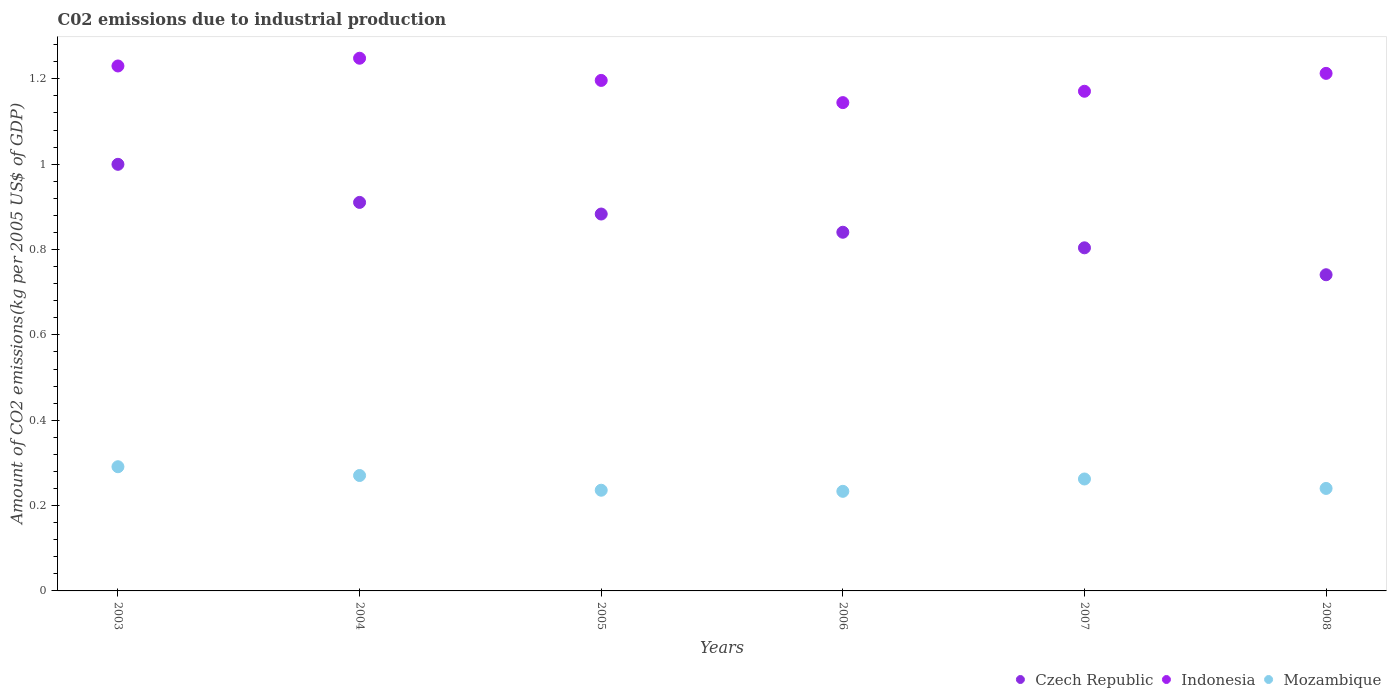Is the number of dotlines equal to the number of legend labels?
Provide a succinct answer. Yes. What is the amount of CO2 emitted due to industrial production in Mozambique in 2004?
Give a very brief answer. 0.27. Across all years, what is the maximum amount of CO2 emitted due to industrial production in Czech Republic?
Provide a succinct answer. 1. Across all years, what is the minimum amount of CO2 emitted due to industrial production in Czech Republic?
Your response must be concise. 0.74. In which year was the amount of CO2 emitted due to industrial production in Czech Republic maximum?
Provide a short and direct response. 2003. In which year was the amount of CO2 emitted due to industrial production in Czech Republic minimum?
Offer a terse response. 2008. What is the total amount of CO2 emitted due to industrial production in Czech Republic in the graph?
Keep it short and to the point. 5.18. What is the difference between the amount of CO2 emitted due to industrial production in Indonesia in 2004 and that in 2007?
Give a very brief answer. 0.08. What is the difference between the amount of CO2 emitted due to industrial production in Indonesia in 2004 and the amount of CO2 emitted due to industrial production in Czech Republic in 2007?
Keep it short and to the point. 0.44. What is the average amount of CO2 emitted due to industrial production in Czech Republic per year?
Your response must be concise. 0.86. In the year 2006, what is the difference between the amount of CO2 emitted due to industrial production in Indonesia and amount of CO2 emitted due to industrial production in Mozambique?
Your answer should be compact. 0.91. In how many years, is the amount of CO2 emitted due to industrial production in Czech Republic greater than 0.7600000000000001 kg?
Provide a short and direct response. 5. What is the ratio of the amount of CO2 emitted due to industrial production in Czech Republic in 2004 to that in 2007?
Provide a short and direct response. 1.13. Is the difference between the amount of CO2 emitted due to industrial production in Indonesia in 2003 and 2004 greater than the difference between the amount of CO2 emitted due to industrial production in Mozambique in 2003 and 2004?
Give a very brief answer. No. What is the difference between the highest and the second highest amount of CO2 emitted due to industrial production in Czech Republic?
Make the answer very short. 0.09. What is the difference between the highest and the lowest amount of CO2 emitted due to industrial production in Mozambique?
Your answer should be very brief. 0.06. In how many years, is the amount of CO2 emitted due to industrial production in Mozambique greater than the average amount of CO2 emitted due to industrial production in Mozambique taken over all years?
Ensure brevity in your answer.  3. Is the sum of the amount of CO2 emitted due to industrial production in Indonesia in 2003 and 2006 greater than the maximum amount of CO2 emitted due to industrial production in Mozambique across all years?
Offer a very short reply. Yes. Is it the case that in every year, the sum of the amount of CO2 emitted due to industrial production in Czech Republic and amount of CO2 emitted due to industrial production in Mozambique  is greater than the amount of CO2 emitted due to industrial production in Indonesia?
Your response must be concise. No. Does the amount of CO2 emitted due to industrial production in Czech Republic monotonically increase over the years?
Provide a short and direct response. No. Is the amount of CO2 emitted due to industrial production in Mozambique strictly greater than the amount of CO2 emitted due to industrial production in Czech Republic over the years?
Make the answer very short. No. Is the amount of CO2 emitted due to industrial production in Indonesia strictly less than the amount of CO2 emitted due to industrial production in Czech Republic over the years?
Offer a terse response. No. How many dotlines are there?
Make the answer very short. 3. How many years are there in the graph?
Provide a succinct answer. 6. Does the graph contain any zero values?
Your answer should be compact. No. How are the legend labels stacked?
Offer a very short reply. Horizontal. What is the title of the graph?
Provide a short and direct response. C02 emissions due to industrial production. Does "Croatia" appear as one of the legend labels in the graph?
Your answer should be very brief. No. What is the label or title of the Y-axis?
Your answer should be very brief. Amount of CO2 emissions(kg per 2005 US$ of GDP). What is the Amount of CO2 emissions(kg per 2005 US$ of GDP) of Czech Republic in 2003?
Your response must be concise. 1. What is the Amount of CO2 emissions(kg per 2005 US$ of GDP) of Indonesia in 2003?
Provide a short and direct response. 1.23. What is the Amount of CO2 emissions(kg per 2005 US$ of GDP) in Mozambique in 2003?
Provide a succinct answer. 0.29. What is the Amount of CO2 emissions(kg per 2005 US$ of GDP) of Czech Republic in 2004?
Provide a short and direct response. 0.91. What is the Amount of CO2 emissions(kg per 2005 US$ of GDP) of Indonesia in 2004?
Your answer should be compact. 1.25. What is the Amount of CO2 emissions(kg per 2005 US$ of GDP) in Mozambique in 2004?
Give a very brief answer. 0.27. What is the Amount of CO2 emissions(kg per 2005 US$ of GDP) of Czech Republic in 2005?
Ensure brevity in your answer.  0.88. What is the Amount of CO2 emissions(kg per 2005 US$ of GDP) of Indonesia in 2005?
Provide a short and direct response. 1.2. What is the Amount of CO2 emissions(kg per 2005 US$ of GDP) in Mozambique in 2005?
Provide a succinct answer. 0.24. What is the Amount of CO2 emissions(kg per 2005 US$ of GDP) of Czech Republic in 2006?
Provide a short and direct response. 0.84. What is the Amount of CO2 emissions(kg per 2005 US$ of GDP) in Indonesia in 2006?
Your answer should be compact. 1.14. What is the Amount of CO2 emissions(kg per 2005 US$ of GDP) of Mozambique in 2006?
Ensure brevity in your answer.  0.23. What is the Amount of CO2 emissions(kg per 2005 US$ of GDP) of Czech Republic in 2007?
Provide a short and direct response. 0.8. What is the Amount of CO2 emissions(kg per 2005 US$ of GDP) of Indonesia in 2007?
Provide a short and direct response. 1.17. What is the Amount of CO2 emissions(kg per 2005 US$ of GDP) of Mozambique in 2007?
Your answer should be compact. 0.26. What is the Amount of CO2 emissions(kg per 2005 US$ of GDP) of Czech Republic in 2008?
Offer a very short reply. 0.74. What is the Amount of CO2 emissions(kg per 2005 US$ of GDP) in Indonesia in 2008?
Give a very brief answer. 1.21. What is the Amount of CO2 emissions(kg per 2005 US$ of GDP) of Mozambique in 2008?
Give a very brief answer. 0.24. Across all years, what is the maximum Amount of CO2 emissions(kg per 2005 US$ of GDP) in Czech Republic?
Make the answer very short. 1. Across all years, what is the maximum Amount of CO2 emissions(kg per 2005 US$ of GDP) of Indonesia?
Offer a terse response. 1.25. Across all years, what is the maximum Amount of CO2 emissions(kg per 2005 US$ of GDP) in Mozambique?
Keep it short and to the point. 0.29. Across all years, what is the minimum Amount of CO2 emissions(kg per 2005 US$ of GDP) of Czech Republic?
Your answer should be compact. 0.74. Across all years, what is the minimum Amount of CO2 emissions(kg per 2005 US$ of GDP) of Indonesia?
Provide a succinct answer. 1.14. Across all years, what is the minimum Amount of CO2 emissions(kg per 2005 US$ of GDP) in Mozambique?
Ensure brevity in your answer.  0.23. What is the total Amount of CO2 emissions(kg per 2005 US$ of GDP) of Czech Republic in the graph?
Your answer should be very brief. 5.18. What is the total Amount of CO2 emissions(kg per 2005 US$ of GDP) in Indonesia in the graph?
Ensure brevity in your answer.  7.2. What is the total Amount of CO2 emissions(kg per 2005 US$ of GDP) in Mozambique in the graph?
Make the answer very short. 1.53. What is the difference between the Amount of CO2 emissions(kg per 2005 US$ of GDP) in Czech Republic in 2003 and that in 2004?
Offer a terse response. 0.09. What is the difference between the Amount of CO2 emissions(kg per 2005 US$ of GDP) of Indonesia in 2003 and that in 2004?
Ensure brevity in your answer.  -0.02. What is the difference between the Amount of CO2 emissions(kg per 2005 US$ of GDP) in Mozambique in 2003 and that in 2004?
Your response must be concise. 0.02. What is the difference between the Amount of CO2 emissions(kg per 2005 US$ of GDP) of Czech Republic in 2003 and that in 2005?
Keep it short and to the point. 0.12. What is the difference between the Amount of CO2 emissions(kg per 2005 US$ of GDP) in Indonesia in 2003 and that in 2005?
Offer a very short reply. 0.03. What is the difference between the Amount of CO2 emissions(kg per 2005 US$ of GDP) in Mozambique in 2003 and that in 2005?
Give a very brief answer. 0.06. What is the difference between the Amount of CO2 emissions(kg per 2005 US$ of GDP) in Czech Republic in 2003 and that in 2006?
Ensure brevity in your answer.  0.16. What is the difference between the Amount of CO2 emissions(kg per 2005 US$ of GDP) of Indonesia in 2003 and that in 2006?
Your answer should be compact. 0.09. What is the difference between the Amount of CO2 emissions(kg per 2005 US$ of GDP) of Mozambique in 2003 and that in 2006?
Provide a short and direct response. 0.06. What is the difference between the Amount of CO2 emissions(kg per 2005 US$ of GDP) of Czech Republic in 2003 and that in 2007?
Give a very brief answer. 0.2. What is the difference between the Amount of CO2 emissions(kg per 2005 US$ of GDP) of Indonesia in 2003 and that in 2007?
Provide a succinct answer. 0.06. What is the difference between the Amount of CO2 emissions(kg per 2005 US$ of GDP) in Mozambique in 2003 and that in 2007?
Provide a succinct answer. 0.03. What is the difference between the Amount of CO2 emissions(kg per 2005 US$ of GDP) of Czech Republic in 2003 and that in 2008?
Offer a terse response. 0.26. What is the difference between the Amount of CO2 emissions(kg per 2005 US$ of GDP) in Indonesia in 2003 and that in 2008?
Keep it short and to the point. 0.02. What is the difference between the Amount of CO2 emissions(kg per 2005 US$ of GDP) in Mozambique in 2003 and that in 2008?
Ensure brevity in your answer.  0.05. What is the difference between the Amount of CO2 emissions(kg per 2005 US$ of GDP) of Czech Republic in 2004 and that in 2005?
Provide a succinct answer. 0.03. What is the difference between the Amount of CO2 emissions(kg per 2005 US$ of GDP) of Indonesia in 2004 and that in 2005?
Offer a terse response. 0.05. What is the difference between the Amount of CO2 emissions(kg per 2005 US$ of GDP) of Mozambique in 2004 and that in 2005?
Your answer should be very brief. 0.03. What is the difference between the Amount of CO2 emissions(kg per 2005 US$ of GDP) of Czech Republic in 2004 and that in 2006?
Provide a short and direct response. 0.07. What is the difference between the Amount of CO2 emissions(kg per 2005 US$ of GDP) in Indonesia in 2004 and that in 2006?
Provide a short and direct response. 0.1. What is the difference between the Amount of CO2 emissions(kg per 2005 US$ of GDP) of Mozambique in 2004 and that in 2006?
Ensure brevity in your answer.  0.04. What is the difference between the Amount of CO2 emissions(kg per 2005 US$ of GDP) of Czech Republic in 2004 and that in 2007?
Your answer should be compact. 0.11. What is the difference between the Amount of CO2 emissions(kg per 2005 US$ of GDP) of Indonesia in 2004 and that in 2007?
Your response must be concise. 0.08. What is the difference between the Amount of CO2 emissions(kg per 2005 US$ of GDP) in Mozambique in 2004 and that in 2007?
Your response must be concise. 0.01. What is the difference between the Amount of CO2 emissions(kg per 2005 US$ of GDP) in Czech Republic in 2004 and that in 2008?
Provide a succinct answer. 0.17. What is the difference between the Amount of CO2 emissions(kg per 2005 US$ of GDP) in Indonesia in 2004 and that in 2008?
Offer a terse response. 0.04. What is the difference between the Amount of CO2 emissions(kg per 2005 US$ of GDP) in Mozambique in 2004 and that in 2008?
Give a very brief answer. 0.03. What is the difference between the Amount of CO2 emissions(kg per 2005 US$ of GDP) of Czech Republic in 2005 and that in 2006?
Provide a succinct answer. 0.04. What is the difference between the Amount of CO2 emissions(kg per 2005 US$ of GDP) of Indonesia in 2005 and that in 2006?
Keep it short and to the point. 0.05. What is the difference between the Amount of CO2 emissions(kg per 2005 US$ of GDP) in Mozambique in 2005 and that in 2006?
Offer a very short reply. 0. What is the difference between the Amount of CO2 emissions(kg per 2005 US$ of GDP) of Czech Republic in 2005 and that in 2007?
Offer a terse response. 0.08. What is the difference between the Amount of CO2 emissions(kg per 2005 US$ of GDP) in Indonesia in 2005 and that in 2007?
Ensure brevity in your answer.  0.03. What is the difference between the Amount of CO2 emissions(kg per 2005 US$ of GDP) in Mozambique in 2005 and that in 2007?
Your answer should be compact. -0.03. What is the difference between the Amount of CO2 emissions(kg per 2005 US$ of GDP) in Czech Republic in 2005 and that in 2008?
Make the answer very short. 0.14. What is the difference between the Amount of CO2 emissions(kg per 2005 US$ of GDP) in Indonesia in 2005 and that in 2008?
Keep it short and to the point. -0.02. What is the difference between the Amount of CO2 emissions(kg per 2005 US$ of GDP) in Mozambique in 2005 and that in 2008?
Your answer should be very brief. -0. What is the difference between the Amount of CO2 emissions(kg per 2005 US$ of GDP) in Czech Republic in 2006 and that in 2007?
Provide a short and direct response. 0.04. What is the difference between the Amount of CO2 emissions(kg per 2005 US$ of GDP) of Indonesia in 2006 and that in 2007?
Make the answer very short. -0.03. What is the difference between the Amount of CO2 emissions(kg per 2005 US$ of GDP) in Mozambique in 2006 and that in 2007?
Make the answer very short. -0.03. What is the difference between the Amount of CO2 emissions(kg per 2005 US$ of GDP) in Czech Republic in 2006 and that in 2008?
Offer a terse response. 0.1. What is the difference between the Amount of CO2 emissions(kg per 2005 US$ of GDP) in Indonesia in 2006 and that in 2008?
Offer a very short reply. -0.07. What is the difference between the Amount of CO2 emissions(kg per 2005 US$ of GDP) of Mozambique in 2006 and that in 2008?
Offer a very short reply. -0.01. What is the difference between the Amount of CO2 emissions(kg per 2005 US$ of GDP) of Czech Republic in 2007 and that in 2008?
Make the answer very short. 0.06. What is the difference between the Amount of CO2 emissions(kg per 2005 US$ of GDP) of Indonesia in 2007 and that in 2008?
Your response must be concise. -0.04. What is the difference between the Amount of CO2 emissions(kg per 2005 US$ of GDP) of Mozambique in 2007 and that in 2008?
Give a very brief answer. 0.02. What is the difference between the Amount of CO2 emissions(kg per 2005 US$ of GDP) of Czech Republic in 2003 and the Amount of CO2 emissions(kg per 2005 US$ of GDP) of Indonesia in 2004?
Give a very brief answer. -0.25. What is the difference between the Amount of CO2 emissions(kg per 2005 US$ of GDP) of Czech Republic in 2003 and the Amount of CO2 emissions(kg per 2005 US$ of GDP) of Mozambique in 2004?
Provide a succinct answer. 0.73. What is the difference between the Amount of CO2 emissions(kg per 2005 US$ of GDP) in Indonesia in 2003 and the Amount of CO2 emissions(kg per 2005 US$ of GDP) in Mozambique in 2004?
Keep it short and to the point. 0.96. What is the difference between the Amount of CO2 emissions(kg per 2005 US$ of GDP) in Czech Republic in 2003 and the Amount of CO2 emissions(kg per 2005 US$ of GDP) in Indonesia in 2005?
Your answer should be compact. -0.2. What is the difference between the Amount of CO2 emissions(kg per 2005 US$ of GDP) of Czech Republic in 2003 and the Amount of CO2 emissions(kg per 2005 US$ of GDP) of Mozambique in 2005?
Provide a short and direct response. 0.76. What is the difference between the Amount of CO2 emissions(kg per 2005 US$ of GDP) of Czech Republic in 2003 and the Amount of CO2 emissions(kg per 2005 US$ of GDP) of Indonesia in 2006?
Ensure brevity in your answer.  -0.14. What is the difference between the Amount of CO2 emissions(kg per 2005 US$ of GDP) of Czech Republic in 2003 and the Amount of CO2 emissions(kg per 2005 US$ of GDP) of Mozambique in 2006?
Give a very brief answer. 0.77. What is the difference between the Amount of CO2 emissions(kg per 2005 US$ of GDP) of Czech Republic in 2003 and the Amount of CO2 emissions(kg per 2005 US$ of GDP) of Indonesia in 2007?
Give a very brief answer. -0.17. What is the difference between the Amount of CO2 emissions(kg per 2005 US$ of GDP) of Czech Republic in 2003 and the Amount of CO2 emissions(kg per 2005 US$ of GDP) of Mozambique in 2007?
Ensure brevity in your answer.  0.74. What is the difference between the Amount of CO2 emissions(kg per 2005 US$ of GDP) of Indonesia in 2003 and the Amount of CO2 emissions(kg per 2005 US$ of GDP) of Mozambique in 2007?
Your response must be concise. 0.97. What is the difference between the Amount of CO2 emissions(kg per 2005 US$ of GDP) in Czech Republic in 2003 and the Amount of CO2 emissions(kg per 2005 US$ of GDP) in Indonesia in 2008?
Keep it short and to the point. -0.21. What is the difference between the Amount of CO2 emissions(kg per 2005 US$ of GDP) in Czech Republic in 2003 and the Amount of CO2 emissions(kg per 2005 US$ of GDP) in Mozambique in 2008?
Keep it short and to the point. 0.76. What is the difference between the Amount of CO2 emissions(kg per 2005 US$ of GDP) of Indonesia in 2003 and the Amount of CO2 emissions(kg per 2005 US$ of GDP) of Mozambique in 2008?
Your answer should be very brief. 0.99. What is the difference between the Amount of CO2 emissions(kg per 2005 US$ of GDP) in Czech Republic in 2004 and the Amount of CO2 emissions(kg per 2005 US$ of GDP) in Indonesia in 2005?
Provide a succinct answer. -0.29. What is the difference between the Amount of CO2 emissions(kg per 2005 US$ of GDP) in Czech Republic in 2004 and the Amount of CO2 emissions(kg per 2005 US$ of GDP) in Mozambique in 2005?
Offer a very short reply. 0.67. What is the difference between the Amount of CO2 emissions(kg per 2005 US$ of GDP) in Indonesia in 2004 and the Amount of CO2 emissions(kg per 2005 US$ of GDP) in Mozambique in 2005?
Keep it short and to the point. 1.01. What is the difference between the Amount of CO2 emissions(kg per 2005 US$ of GDP) of Czech Republic in 2004 and the Amount of CO2 emissions(kg per 2005 US$ of GDP) of Indonesia in 2006?
Offer a very short reply. -0.23. What is the difference between the Amount of CO2 emissions(kg per 2005 US$ of GDP) of Czech Republic in 2004 and the Amount of CO2 emissions(kg per 2005 US$ of GDP) of Mozambique in 2006?
Make the answer very short. 0.68. What is the difference between the Amount of CO2 emissions(kg per 2005 US$ of GDP) of Indonesia in 2004 and the Amount of CO2 emissions(kg per 2005 US$ of GDP) of Mozambique in 2006?
Your answer should be very brief. 1.01. What is the difference between the Amount of CO2 emissions(kg per 2005 US$ of GDP) in Czech Republic in 2004 and the Amount of CO2 emissions(kg per 2005 US$ of GDP) in Indonesia in 2007?
Ensure brevity in your answer.  -0.26. What is the difference between the Amount of CO2 emissions(kg per 2005 US$ of GDP) of Czech Republic in 2004 and the Amount of CO2 emissions(kg per 2005 US$ of GDP) of Mozambique in 2007?
Your answer should be compact. 0.65. What is the difference between the Amount of CO2 emissions(kg per 2005 US$ of GDP) in Czech Republic in 2004 and the Amount of CO2 emissions(kg per 2005 US$ of GDP) in Indonesia in 2008?
Give a very brief answer. -0.3. What is the difference between the Amount of CO2 emissions(kg per 2005 US$ of GDP) of Czech Republic in 2004 and the Amount of CO2 emissions(kg per 2005 US$ of GDP) of Mozambique in 2008?
Offer a very short reply. 0.67. What is the difference between the Amount of CO2 emissions(kg per 2005 US$ of GDP) in Indonesia in 2004 and the Amount of CO2 emissions(kg per 2005 US$ of GDP) in Mozambique in 2008?
Offer a terse response. 1.01. What is the difference between the Amount of CO2 emissions(kg per 2005 US$ of GDP) of Czech Republic in 2005 and the Amount of CO2 emissions(kg per 2005 US$ of GDP) of Indonesia in 2006?
Ensure brevity in your answer.  -0.26. What is the difference between the Amount of CO2 emissions(kg per 2005 US$ of GDP) of Czech Republic in 2005 and the Amount of CO2 emissions(kg per 2005 US$ of GDP) of Mozambique in 2006?
Your response must be concise. 0.65. What is the difference between the Amount of CO2 emissions(kg per 2005 US$ of GDP) of Indonesia in 2005 and the Amount of CO2 emissions(kg per 2005 US$ of GDP) of Mozambique in 2006?
Ensure brevity in your answer.  0.96. What is the difference between the Amount of CO2 emissions(kg per 2005 US$ of GDP) in Czech Republic in 2005 and the Amount of CO2 emissions(kg per 2005 US$ of GDP) in Indonesia in 2007?
Offer a very short reply. -0.29. What is the difference between the Amount of CO2 emissions(kg per 2005 US$ of GDP) of Czech Republic in 2005 and the Amount of CO2 emissions(kg per 2005 US$ of GDP) of Mozambique in 2007?
Your answer should be very brief. 0.62. What is the difference between the Amount of CO2 emissions(kg per 2005 US$ of GDP) in Indonesia in 2005 and the Amount of CO2 emissions(kg per 2005 US$ of GDP) in Mozambique in 2007?
Your answer should be very brief. 0.93. What is the difference between the Amount of CO2 emissions(kg per 2005 US$ of GDP) of Czech Republic in 2005 and the Amount of CO2 emissions(kg per 2005 US$ of GDP) of Indonesia in 2008?
Make the answer very short. -0.33. What is the difference between the Amount of CO2 emissions(kg per 2005 US$ of GDP) in Czech Republic in 2005 and the Amount of CO2 emissions(kg per 2005 US$ of GDP) in Mozambique in 2008?
Your answer should be very brief. 0.64. What is the difference between the Amount of CO2 emissions(kg per 2005 US$ of GDP) of Indonesia in 2005 and the Amount of CO2 emissions(kg per 2005 US$ of GDP) of Mozambique in 2008?
Your answer should be very brief. 0.96. What is the difference between the Amount of CO2 emissions(kg per 2005 US$ of GDP) in Czech Republic in 2006 and the Amount of CO2 emissions(kg per 2005 US$ of GDP) in Indonesia in 2007?
Make the answer very short. -0.33. What is the difference between the Amount of CO2 emissions(kg per 2005 US$ of GDP) of Czech Republic in 2006 and the Amount of CO2 emissions(kg per 2005 US$ of GDP) of Mozambique in 2007?
Your response must be concise. 0.58. What is the difference between the Amount of CO2 emissions(kg per 2005 US$ of GDP) in Indonesia in 2006 and the Amount of CO2 emissions(kg per 2005 US$ of GDP) in Mozambique in 2007?
Provide a succinct answer. 0.88. What is the difference between the Amount of CO2 emissions(kg per 2005 US$ of GDP) in Czech Republic in 2006 and the Amount of CO2 emissions(kg per 2005 US$ of GDP) in Indonesia in 2008?
Your answer should be very brief. -0.37. What is the difference between the Amount of CO2 emissions(kg per 2005 US$ of GDP) of Czech Republic in 2006 and the Amount of CO2 emissions(kg per 2005 US$ of GDP) of Mozambique in 2008?
Keep it short and to the point. 0.6. What is the difference between the Amount of CO2 emissions(kg per 2005 US$ of GDP) in Indonesia in 2006 and the Amount of CO2 emissions(kg per 2005 US$ of GDP) in Mozambique in 2008?
Provide a short and direct response. 0.9. What is the difference between the Amount of CO2 emissions(kg per 2005 US$ of GDP) of Czech Republic in 2007 and the Amount of CO2 emissions(kg per 2005 US$ of GDP) of Indonesia in 2008?
Offer a very short reply. -0.41. What is the difference between the Amount of CO2 emissions(kg per 2005 US$ of GDP) in Czech Republic in 2007 and the Amount of CO2 emissions(kg per 2005 US$ of GDP) in Mozambique in 2008?
Provide a succinct answer. 0.56. What is the difference between the Amount of CO2 emissions(kg per 2005 US$ of GDP) of Indonesia in 2007 and the Amount of CO2 emissions(kg per 2005 US$ of GDP) of Mozambique in 2008?
Provide a succinct answer. 0.93. What is the average Amount of CO2 emissions(kg per 2005 US$ of GDP) in Czech Republic per year?
Your response must be concise. 0.86. What is the average Amount of CO2 emissions(kg per 2005 US$ of GDP) in Indonesia per year?
Provide a short and direct response. 1.2. What is the average Amount of CO2 emissions(kg per 2005 US$ of GDP) of Mozambique per year?
Your answer should be compact. 0.26. In the year 2003, what is the difference between the Amount of CO2 emissions(kg per 2005 US$ of GDP) of Czech Republic and Amount of CO2 emissions(kg per 2005 US$ of GDP) of Indonesia?
Offer a terse response. -0.23. In the year 2003, what is the difference between the Amount of CO2 emissions(kg per 2005 US$ of GDP) of Czech Republic and Amount of CO2 emissions(kg per 2005 US$ of GDP) of Mozambique?
Keep it short and to the point. 0.71. In the year 2003, what is the difference between the Amount of CO2 emissions(kg per 2005 US$ of GDP) of Indonesia and Amount of CO2 emissions(kg per 2005 US$ of GDP) of Mozambique?
Provide a succinct answer. 0.94. In the year 2004, what is the difference between the Amount of CO2 emissions(kg per 2005 US$ of GDP) in Czech Republic and Amount of CO2 emissions(kg per 2005 US$ of GDP) in Indonesia?
Your response must be concise. -0.34. In the year 2004, what is the difference between the Amount of CO2 emissions(kg per 2005 US$ of GDP) of Czech Republic and Amount of CO2 emissions(kg per 2005 US$ of GDP) of Mozambique?
Offer a terse response. 0.64. In the year 2004, what is the difference between the Amount of CO2 emissions(kg per 2005 US$ of GDP) in Indonesia and Amount of CO2 emissions(kg per 2005 US$ of GDP) in Mozambique?
Ensure brevity in your answer.  0.98. In the year 2005, what is the difference between the Amount of CO2 emissions(kg per 2005 US$ of GDP) of Czech Republic and Amount of CO2 emissions(kg per 2005 US$ of GDP) of Indonesia?
Your answer should be compact. -0.31. In the year 2005, what is the difference between the Amount of CO2 emissions(kg per 2005 US$ of GDP) of Czech Republic and Amount of CO2 emissions(kg per 2005 US$ of GDP) of Mozambique?
Provide a succinct answer. 0.65. In the year 2005, what is the difference between the Amount of CO2 emissions(kg per 2005 US$ of GDP) of Indonesia and Amount of CO2 emissions(kg per 2005 US$ of GDP) of Mozambique?
Provide a succinct answer. 0.96. In the year 2006, what is the difference between the Amount of CO2 emissions(kg per 2005 US$ of GDP) of Czech Republic and Amount of CO2 emissions(kg per 2005 US$ of GDP) of Indonesia?
Your answer should be very brief. -0.3. In the year 2006, what is the difference between the Amount of CO2 emissions(kg per 2005 US$ of GDP) of Czech Republic and Amount of CO2 emissions(kg per 2005 US$ of GDP) of Mozambique?
Provide a short and direct response. 0.61. In the year 2006, what is the difference between the Amount of CO2 emissions(kg per 2005 US$ of GDP) of Indonesia and Amount of CO2 emissions(kg per 2005 US$ of GDP) of Mozambique?
Your answer should be very brief. 0.91. In the year 2007, what is the difference between the Amount of CO2 emissions(kg per 2005 US$ of GDP) in Czech Republic and Amount of CO2 emissions(kg per 2005 US$ of GDP) in Indonesia?
Your answer should be compact. -0.37. In the year 2007, what is the difference between the Amount of CO2 emissions(kg per 2005 US$ of GDP) in Czech Republic and Amount of CO2 emissions(kg per 2005 US$ of GDP) in Mozambique?
Offer a very short reply. 0.54. In the year 2007, what is the difference between the Amount of CO2 emissions(kg per 2005 US$ of GDP) of Indonesia and Amount of CO2 emissions(kg per 2005 US$ of GDP) of Mozambique?
Offer a very short reply. 0.91. In the year 2008, what is the difference between the Amount of CO2 emissions(kg per 2005 US$ of GDP) in Czech Republic and Amount of CO2 emissions(kg per 2005 US$ of GDP) in Indonesia?
Your answer should be very brief. -0.47. In the year 2008, what is the difference between the Amount of CO2 emissions(kg per 2005 US$ of GDP) of Czech Republic and Amount of CO2 emissions(kg per 2005 US$ of GDP) of Mozambique?
Your answer should be very brief. 0.5. In the year 2008, what is the difference between the Amount of CO2 emissions(kg per 2005 US$ of GDP) in Indonesia and Amount of CO2 emissions(kg per 2005 US$ of GDP) in Mozambique?
Provide a short and direct response. 0.97. What is the ratio of the Amount of CO2 emissions(kg per 2005 US$ of GDP) in Czech Republic in 2003 to that in 2004?
Keep it short and to the point. 1.1. What is the ratio of the Amount of CO2 emissions(kg per 2005 US$ of GDP) of Indonesia in 2003 to that in 2004?
Your answer should be very brief. 0.99. What is the ratio of the Amount of CO2 emissions(kg per 2005 US$ of GDP) of Mozambique in 2003 to that in 2004?
Your response must be concise. 1.08. What is the ratio of the Amount of CO2 emissions(kg per 2005 US$ of GDP) of Czech Republic in 2003 to that in 2005?
Give a very brief answer. 1.13. What is the ratio of the Amount of CO2 emissions(kg per 2005 US$ of GDP) in Indonesia in 2003 to that in 2005?
Provide a succinct answer. 1.03. What is the ratio of the Amount of CO2 emissions(kg per 2005 US$ of GDP) of Mozambique in 2003 to that in 2005?
Ensure brevity in your answer.  1.23. What is the ratio of the Amount of CO2 emissions(kg per 2005 US$ of GDP) in Czech Republic in 2003 to that in 2006?
Give a very brief answer. 1.19. What is the ratio of the Amount of CO2 emissions(kg per 2005 US$ of GDP) in Indonesia in 2003 to that in 2006?
Your answer should be compact. 1.07. What is the ratio of the Amount of CO2 emissions(kg per 2005 US$ of GDP) of Mozambique in 2003 to that in 2006?
Keep it short and to the point. 1.25. What is the ratio of the Amount of CO2 emissions(kg per 2005 US$ of GDP) of Czech Republic in 2003 to that in 2007?
Make the answer very short. 1.24. What is the ratio of the Amount of CO2 emissions(kg per 2005 US$ of GDP) in Indonesia in 2003 to that in 2007?
Provide a short and direct response. 1.05. What is the ratio of the Amount of CO2 emissions(kg per 2005 US$ of GDP) of Mozambique in 2003 to that in 2007?
Ensure brevity in your answer.  1.11. What is the ratio of the Amount of CO2 emissions(kg per 2005 US$ of GDP) of Czech Republic in 2003 to that in 2008?
Keep it short and to the point. 1.35. What is the ratio of the Amount of CO2 emissions(kg per 2005 US$ of GDP) of Indonesia in 2003 to that in 2008?
Make the answer very short. 1.01. What is the ratio of the Amount of CO2 emissions(kg per 2005 US$ of GDP) in Mozambique in 2003 to that in 2008?
Your response must be concise. 1.21. What is the ratio of the Amount of CO2 emissions(kg per 2005 US$ of GDP) in Czech Republic in 2004 to that in 2005?
Give a very brief answer. 1.03. What is the ratio of the Amount of CO2 emissions(kg per 2005 US$ of GDP) of Indonesia in 2004 to that in 2005?
Make the answer very short. 1.04. What is the ratio of the Amount of CO2 emissions(kg per 2005 US$ of GDP) in Mozambique in 2004 to that in 2005?
Keep it short and to the point. 1.15. What is the ratio of the Amount of CO2 emissions(kg per 2005 US$ of GDP) in Czech Republic in 2004 to that in 2006?
Your answer should be compact. 1.08. What is the ratio of the Amount of CO2 emissions(kg per 2005 US$ of GDP) of Mozambique in 2004 to that in 2006?
Your answer should be very brief. 1.16. What is the ratio of the Amount of CO2 emissions(kg per 2005 US$ of GDP) of Czech Republic in 2004 to that in 2007?
Ensure brevity in your answer.  1.13. What is the ratio of the Amount of CO2 emissions(kg per 2005 US$ of GDP) of Indonesia in 2004 to that in 2007?
Give a very brief answer. 1.07. What is the ratio of the Amount of CO2 emissions(kg per 2005 US$ of GDP) of Mozambique in 2004 to that in 2007?
Your answer should be very brief. 1.03. What is the ratio of the Amount of CO2 emissions(kg per 2005 US$ of GDP) in Czech Republic in 2004 to that in 2008?
Offer a terse response. 1.23. What is the ratio of the Amount of CO2 emissions(kg per 2005 US$ of GDP) of Indonesia in 2004 to that in 2008?
Give a very brief answer. 1.03. What is the ratio of the Amount of CO2 emissions(kg per 2005 US$ of GDP) of Mozambique in 2004 to that in 2008?
Provide a short and direct response. 1.13. What is the ratio of the Amount of CO2 emissions(kg per 2005 US$ of GDP) of Czech Republic in 2005 to that in 2006?
Your response must be concise. 1.05. What is the ratio of the Amount of CO2 emissions(kg per 2005 US$ of GDP) of Indonesia in 2005 to that in 2006?
Provide a succinct answer. 1.05. What is the ratio of the Amount of CO2 emissions(kg per 2005 US$ of GDP) in Czech Republic in 2005 to that in 2007?
Make the answer very short. 1.1. What is the ratio of the Amount of CO2 emissions(kg per 2005 US$ of GDP) of Indonesia in 2005 to that in 2007?
Your response must be concise. 1.02. What is the ratio of the Amount of CO2 emissions(kg per 2005 US$ of GDP) in Mozambique in 2005 to that in 2007?
Your answer should be very brief. 0.9. What is the ratio of the Amount of CO2 emissions(kg per 2005 US$ of GDP) of Czech Republic in 2005 to that in 2008?
Ensure brevity in your answer.  1.19. What is the ratio of the Amount of CO2 emissions(kg per 2005 US$ of GDP) of Indonesia in 2005 to that in 2008?
Make the answer very short. 0.99. What is the ratio of the Amount of CO2 emissions(kg per 2005 US$ of GDP) in Mozambique in 2005 to that in 2008?
Make the answer very short. 0.98. What is the ratio of the Amount of CO2 emissions(kg per 2005 US$ of GDP) of Czech Republic in 2006 to that in 2007?
Your answer should be very brief. 1.05. What is the ratio of the Amount of CO2 emissions(kg per 2005 US$ of GDP) in Indonesia in 2006 to that in 2007?
Give a very brief answer. 0.98. What is the ratio of the Amount of CO2 emissions(kg per 2005 US$ of GDP) in Mozambique in 2006 to that in 2007?
Ensure brevity in your answer.  0.89. What is the ratio of the Amount of CO2 emissions(kg per 2005 US$ of GDP) in Czech Republic in 2006 to that in 2008?
Provide a succinct answer. 1.13. What is the ratio of the Amount of CO2 emissions(kg per 2005 US$ of GDP) in Indonesia in 2006 to that in 2008?
Ensure brevity in your answer.  0.94. What is the ratio of the Amount of CO2 emissions(kg per 2005 US$ of GDP) of Mozambique in 2006 to that in 2008?
Make the answer very short. 0.97. What is the ratio of the Amount of CO2 emissions(kg per 2005 US$ of GDP) in Czech Republic in 2007 to that in 2008?
Your answer should be very brief. 1.09. What is the ratio of the Amount of CO2 emissions(kg per 2005 US$ of GDP) of Indonesia in 2007 to that in 2008?
Keep it short and to the point. 0.97. What is the ratio of the Amount of CO2 emissions(kg per 2005 US$ of GDP) in Mozambique in 2007 to that in 2008?
Give a very brief answer. 1.09. What is the difference between the highest and the second highest Amount of CO2 emissions(kg per 2005 US$ of GDP) of Czech Republic?
Offer a very short reply. 0.09. What is the difference between the highest and the second highest Amount of CO2 emissions(kg per 2005 US$ of GDP) in Indonesia?
Offer a terse response. 0.02. What is the difference between the highest and the second highest Amount of CO2 emissions(kg per 2005 US$ of GDP) of Mozambique?
Your response must be concise. 0.02. What is the difference between the highest and the lowest Amount of CO2 emissions(kg per 2005 US$ of GDP) in Czech Republic?
Provide a succinct answer. 0.26. What is the difference between the highest and the lowest Amount of CO2 emissions(kg per 2005 US$ of GDP) in Indonesia?
Offer a very short reply. 0.1. What is the difference between the highest and the lowest Amount of CO2 emissions(kg per 2005 US$ of GDP) in Mozambique?
Provide a short and direct response. 0.06. 